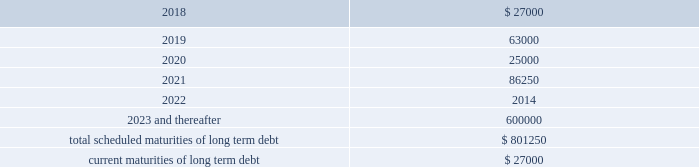Other long term debt in december 2012 , the company entered into a $ 50.0 million recourse loan collateralized by the land , buildings and tenant improvements comprising the company 2019s corporate headquarters .
The loan has a seven year term and maturity date of december 2019 .
The loan bears interest at one month libor plus a margin of 1.50% ( 1.50 % ) , and allows for prepayment without penalty .
The loan includes covenants and events of default substantially consistent with the company 2019s credit agreement discussed above .
The loan also requires prior approval of the lender for certain matters related to the property , including transfers of any interest in the property .
As of december 31 , 2017 and 2016 , the outstanding balance on the loan was $ 40.0 million and $ 42.0 million , respectively .
The weighted average interest rate on the loan was 2.5% ( 2.5 % ) and 2.0% ( 2.0 % ) for the years ended december 31 , 2017 and 2016 , respectively .
The following are the scheduled maturities of long term debt as of december 31 , 2017 : ( in thousands ) .
Interest expense , net was $ 34.5 million , $ 26.4 million , and $ 14.6 million for the years ended december 31 , 2017 , 2016 and 2015 , respectively .
Interest expense includes the amortization of deferred financing costs , bank fees , capital and built-to-suit lease interest and interest expense under the credit and other long term debt facilities .
Amortization of deferred financing costs was $ 1.3 million , $ 1.2 million , and $ 0.8 million for the years ended december 31 , 2017 , 2016 and 2015 , respectively .
The company monitors the financial health and stability of its lenders under the credit and other long term debt facilities , however during any period of significant instability in the credit markets lenders could be negatively impacted in their ability to perform under these facilities .
Commitments and contingencies obligations under operating leases the company leases warehouse space , office facilities , space for its brand and factory house stores and certain equipment under non-cancelable operating leases .
The leases expire at various dates through 2033 , excluding extensions at the company 2019s option , and include provisions for rental adjustments .
The table below includes executed lease agreements for brand and factory house stores that the company did not yet occupy as of december 31 , 2017 and does not include contingent rent the company may incur at its stores based on future sales above a specified minimum or payments made for maintenance , insurance and real estate taxes .
The following is a schedule of future minimum lease payments for non-cancelable real property operating leases as of december 31 , 2017 as well as .
What was the percentage change in interest expense net from 2015 to 2016? 
Computations: ((26.4 - 14.6) / 14.6)
Answer: 0.80822. 